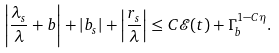Convert formula to latex. <formula><loc_0><loc_0><loc_500><loc_500>\left | \frac { \lambda _ { s } } { \lambda } + b \right | + | b _ { s } | + \left | \frac { r _ { s } } { \lambda } \right | \leq C \mathcal { E } ( t ) + \Gamma _ { b } ^ { 1 - C \eta } .</formula> 